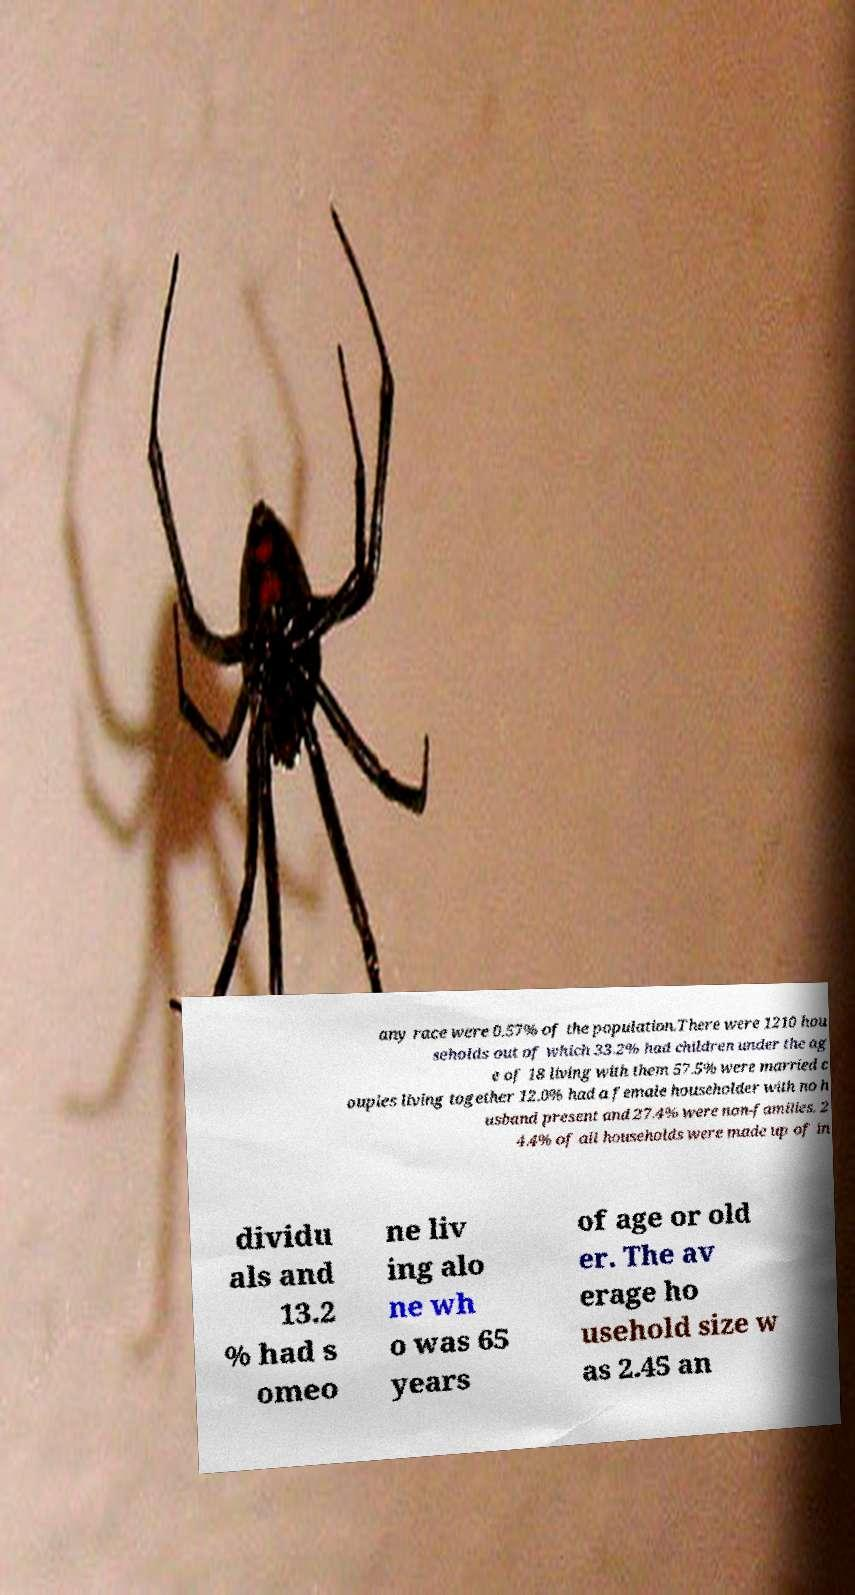Could you assist in decoding the text presented in this image and type it out clearly? any race were 0.57% of the population.There were 1210 hou seholds out of which 33.2% had children under the ag e of 18 living with them 57.5% were married c ouples living together 12.0% had a female householder with no h usband present and 27.4% were non-families. 2 4.4% of all households were made up of in dividu als and 13.2 % had s omeo ne liv ing alo ne wh o was 65 years of age or old er. The av erage ho usehold size w as 2.45 an 